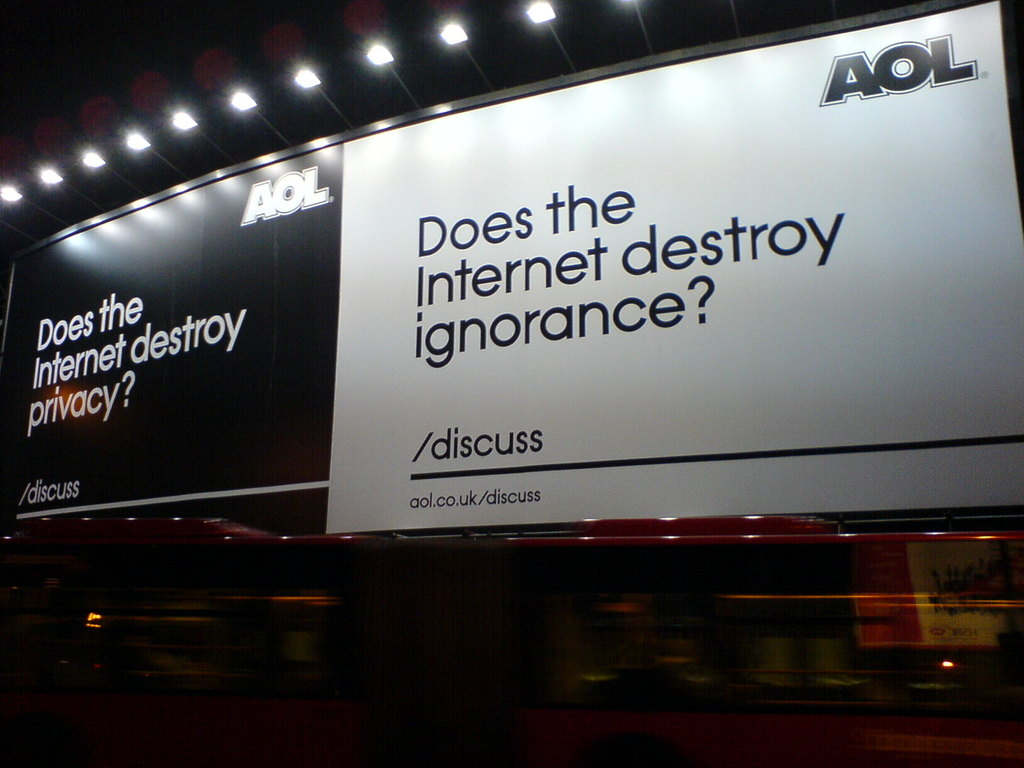How might the Internet help in reducing ignorance? The Internet, as a vast repository of information, offers unprecedented access to knowledge which can challenge ignorance. It allows users to access educational resources, expert opinions, and cultural insights beyond geographical and socio-economic barriers. However, the effectiveness of the Internet in reducing ignorance also depends on digital literacy skills to discern credible information from misinformation. 